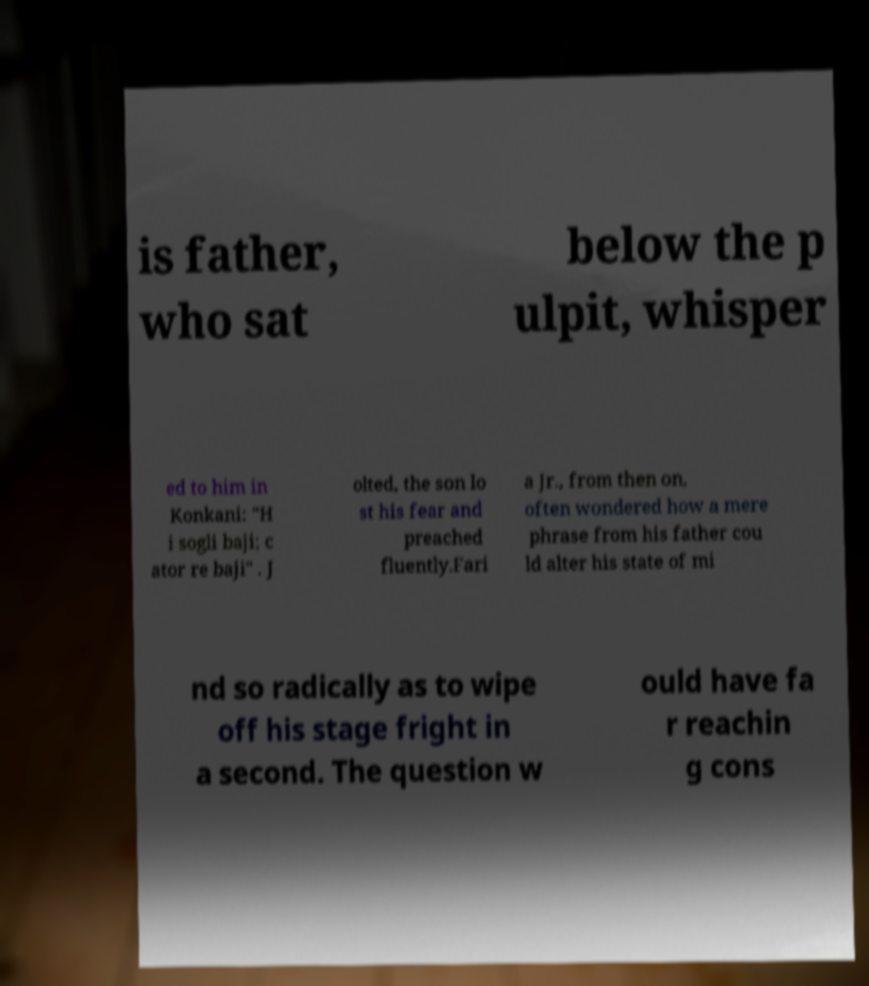For documentation purposes, I need the text within this image transcribed. Could you provide that? is father, who sat below the p ulpit, whisper ed to him in Konkani: "H i sogli baji; c ator re baji" . J olted, the son lo st his fear and preached fluently.Fari a Jr., from then on, often wondered how a mere phrase from his father cou ld alter his state of mi nd so radically as to wipe off his stage fright in a second. The question w ould have fa r reachin g cons 